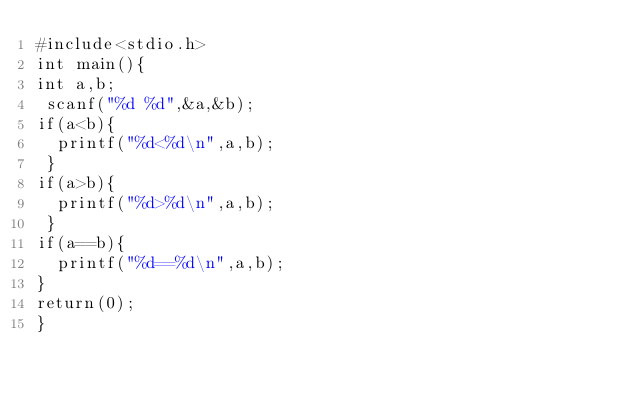Convert code to text. <code><loc_0><loc_0><loc_500><loc_500><_C++_>#include<stdio.h>
int main(){
int a,b;
 scanf("%d %d",&a,&b);
if(a<b){
  printf("%d<%d\n",a,b);
 }
if(a>b){
  printf("%d>%d\n",a,b);
 }
if(a==b){
  printf("%d==%d\n",a,b);
}
return(0);
}
 </code> 